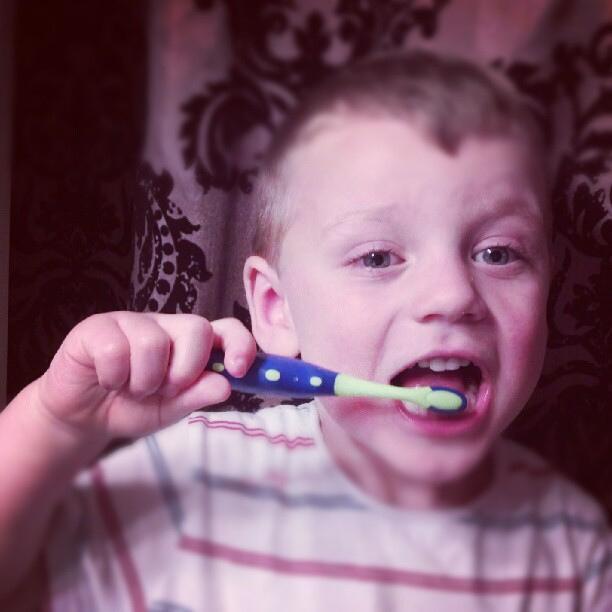How many toothbrushes are visible?
Give a very brief answer. 1. 